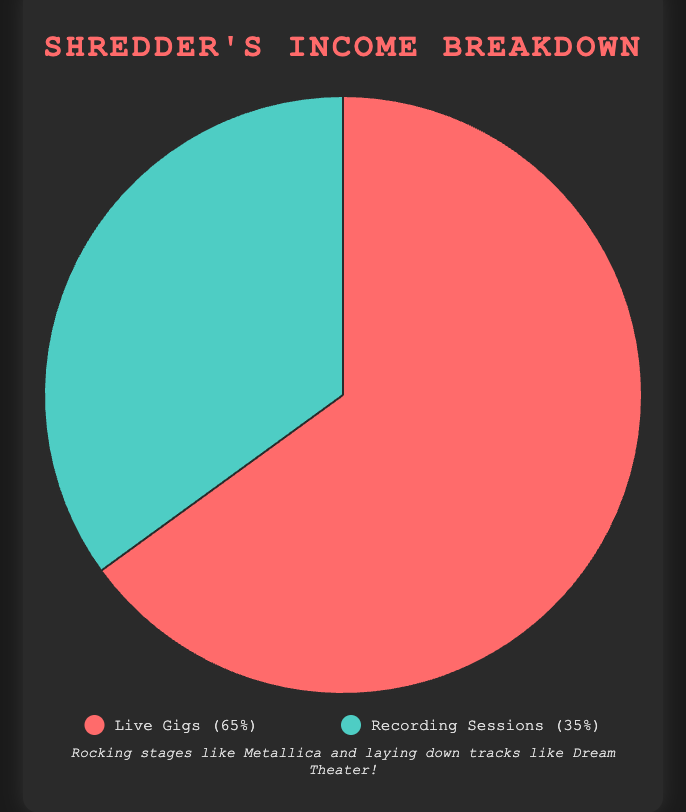Which income source has a higher percentage? The pie chart shows that Live Gigs have a higher percentage compared to Recording Sessions. Live Gigs make up 65% of the income, while Recording Sessions contribute 35%
Answer: Live Gigs Which source contributes less to the overall income? According to the chart, Recording Sessions contribute less to the overall income compared to Live Gigs. Recording Sessions constitute 35% of the total income
Answer: Recording Sessions What is the difference in percentage between income from Live Gigs and Recording Sessions? Live Gigs account for 65% and Recording Sessions for 35%. The difference is calculated by subtracting the percentage for Recording Sessions from Live Gigs: 65% - 35% = 30%
Answer: 30% If the total income is $100,000, how much comes from Recording Sessions? First, identify the percentage for Recording Sessions, which is 35%. Calculate 35% of $100,000 by multiplying: (35/100) * 100,000 = $35,000
Answer: $35,000 If income from Live Gigs increased by 10%, what would be their new percentage of the total income? Starting with 65%, if Live Gigs increased by 10%, add this percentage incrementally: 65% + 10% = 75%
Answer: 75% What color represents income from Recording Sessions in the pie chart? The legend indicates that the color representing Recording Sessions is blue (a shade of blue-green, specifically)
Answer: Blue What income source could be associated with Dream Theater according to the description? The description explains that income from Recording Sessions is linked to bands like Dream Theater, who generate income from recording albums and studio work
Answer: Recording Sessions If the percentage for Recording Sessions was doubled, what would be the new percentages for both sources? Doubling the current percentage of Recording Sessions from 35% results in 70%. Consequently, to maintain 100% total, Live Gigs would adjust: 100% - 70% = 30%
Answer: Recording Sessions: 70%, Live Gigs: 30% How does the income structure change when bands like Metallica primarily contribute to Live Gigs? The chart shows that bands like Metallica influence the dominance of Live Gigs due to their high-energy performances and tours, giving Live Gigs a higher percentage at 65%
Answer: More income from Live Gigs 